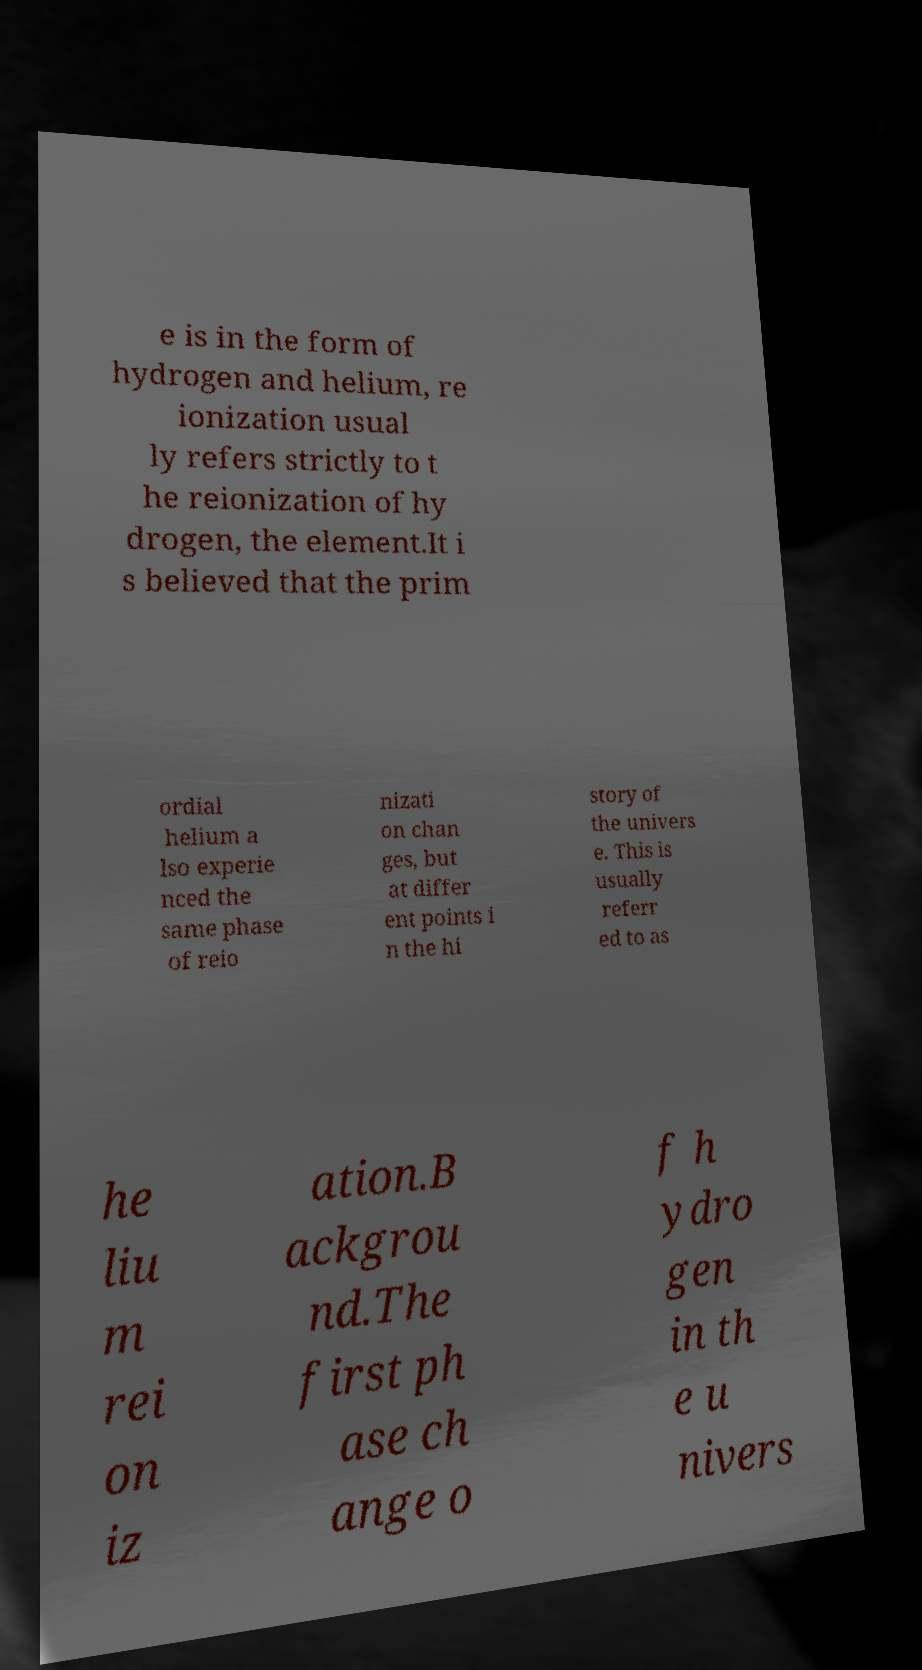What messages or text are displayed in this image? I need them in a readable, typed format. e is in the form of hydrogen and helium, re ionization usual ly refers strictly to t he reionization of hy drogen, the element.It i s believed that the prim ordial helium a lso experie nced the same phase of reio nizati on chan ges, but at differ ent points i n the hi story of the univers e. This is usually referr ed to as he liu m rei on iz ation.B ackgrou nd.The first ph ase ch ange o f h ydro gen in th e u nivers 